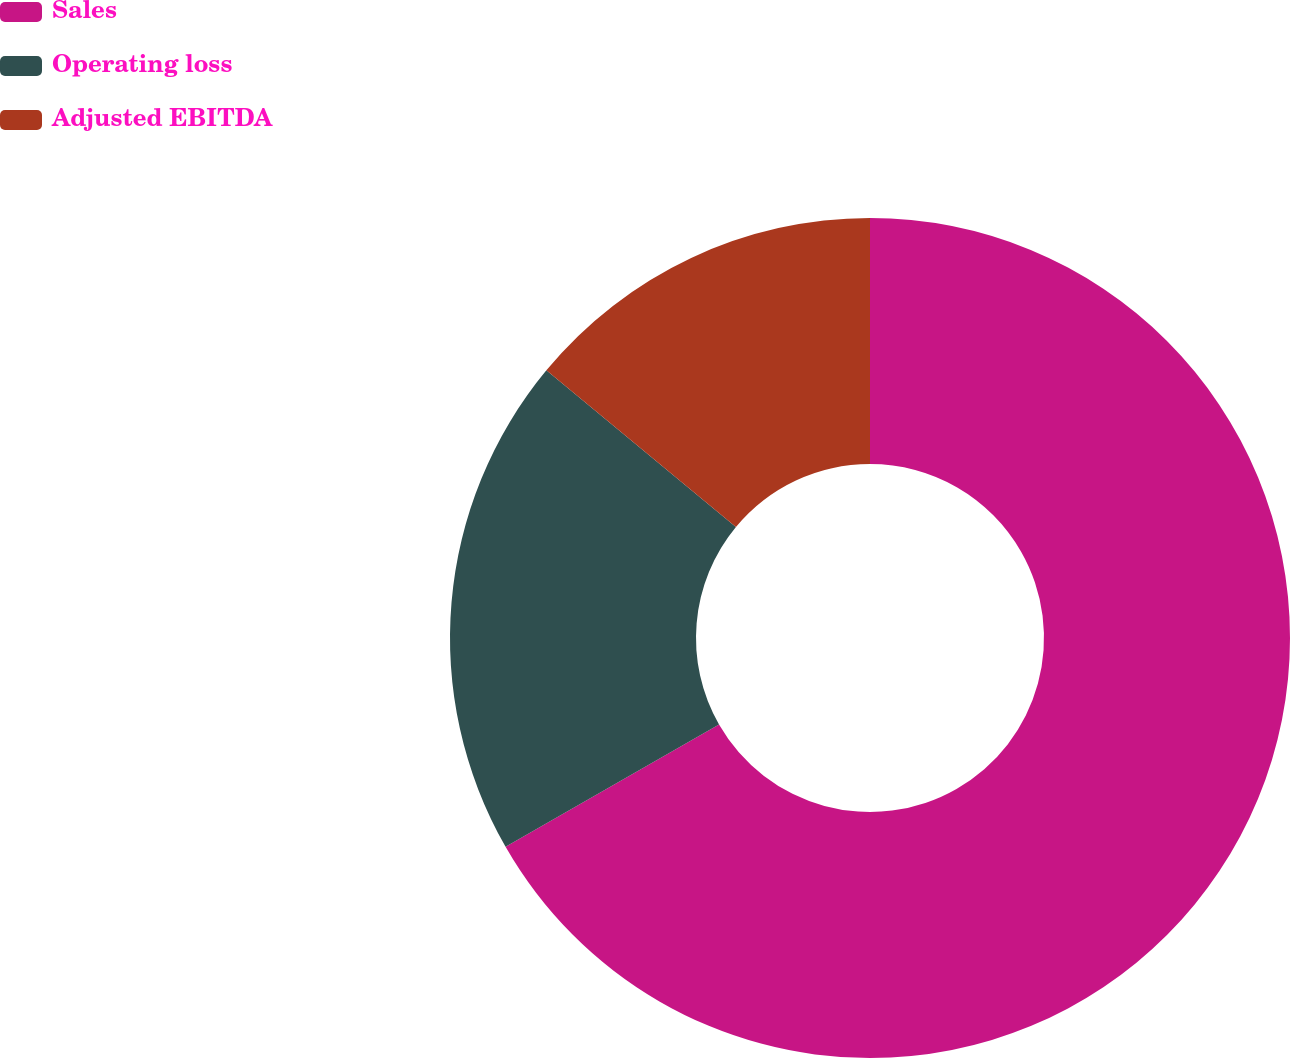<chart> <loc_0><loc_0><loc_500><loc_500><pie_chart><fcel>Sales<fcel>Operating loss<fcel>Adjusted EBITDA<nl><fcel>66.72%<fcel>19.28%<fcel>14.0%<nl></chart> 